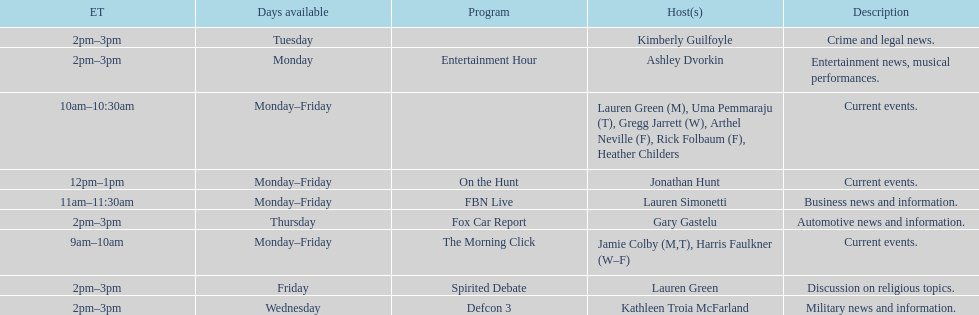What is the first show to play on monday mornings? The Morning Click. 